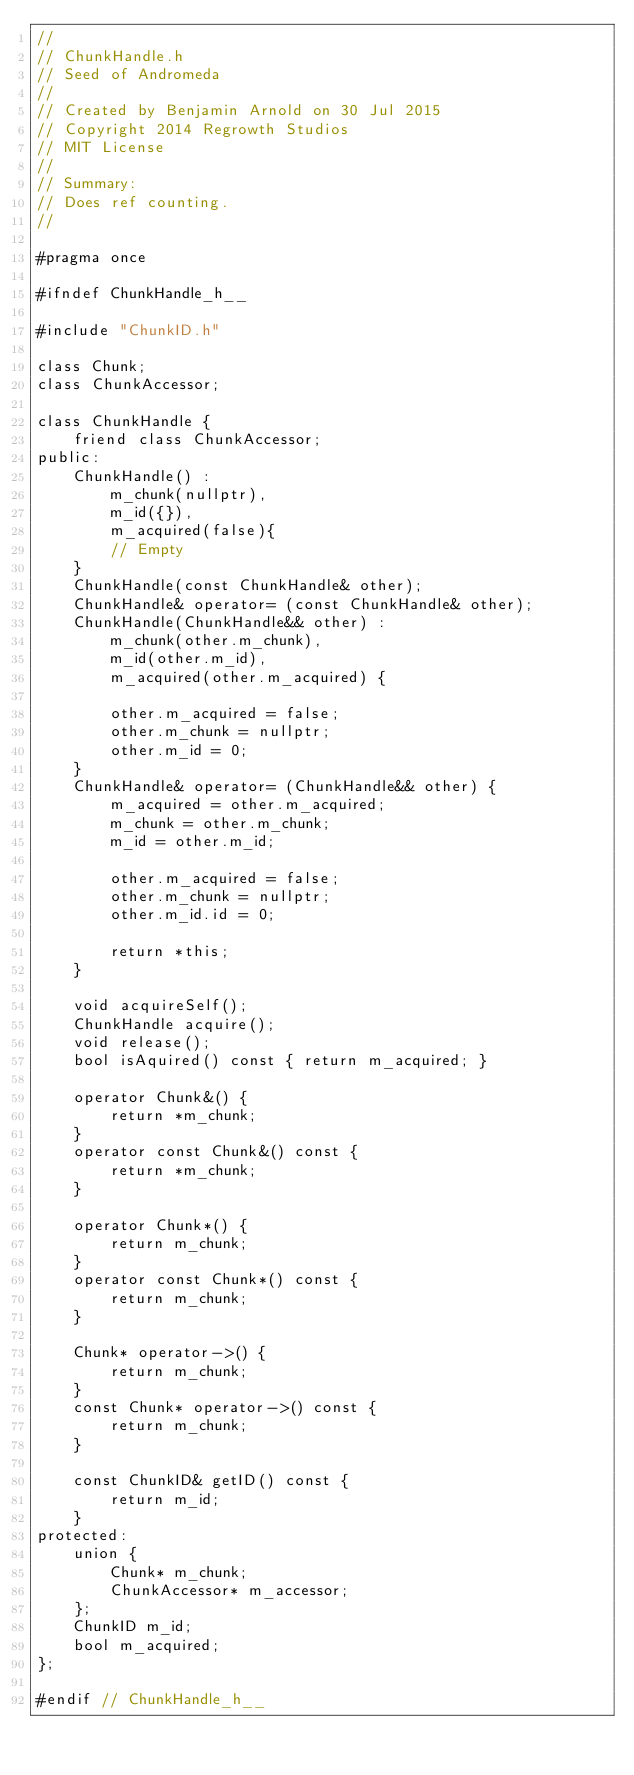Convert code to text. <code><loc_0><loc_0><loc_500><loc_500><_C_>//
// ChunkHandle.h
// Seed of Andromeda
//
// Created by Benjamin Arnold on 30 Jul 2015
// Copyright 2014 Regrowth Studios
// MIT License
//
// Summary:
// Does ref counting.
//

#pragma once

#ifndef ChunkHandle_h__

#include "ChunkID.h"

class Chunk;
class ChunkAccessor;

class ChunkHandle {
    friend class ChunkAccessor;
public:
    ChunkHandle() : 
        m_chunk(nullptr),
        m_id({}),
        m_acquired(false){
        // Empty
    }
    ChunkHandle(const ChunkHandle& other);
    ChunkHandle& operator= (const ChunkHandle& other);
    ChunkHandle(ChunkHandle&& other) :
        m_chunk(other.m_chunk),
        m_id(other.m_id),
        m_acquired(other.m_acquired) {

        other.m_acquired = false;
        other.m_chunk = nullptr;
        other.m_id = 0;
    }
    ChunkHandle& operator= (ChunkHandle&& other) {
        m_acquired = other.m_acquired;
        m_chunk = other.m_chunk;
        m_id = other.m_id;

        other.m_acquired = false;
        other.m_chunk = nullptr;
        other.m_id.id = 0;

        return *this;
    }

    void acquireSelf();
    ChunkHandle acquire();
    void release();
    bool isAquired() const { return m_acquired; }

    operator Chunk&() {
        return *m_chunk;
    }
    operator const Chunk&() const {
        return *m_chunk;
    }

    operator Chunk*() {
        return m_chunk;
    }
    operator const Chunk*() const {
        return m_chunk;
    }

    Chunk* operator->() {
        return m_chunk;
    }
    const Chunk* operator->() const {
        return m_chunk;
    }

    const ChunkID& getID() const {
        return m_id;
    }
protected:
    union {
        Chunk* m_chunk;
        ChunkAccessor* m_accessor;
    };
    ChunkID m_id;
    bool m_acquired;
};

#endif // ChunkHandle_h__
</code> 